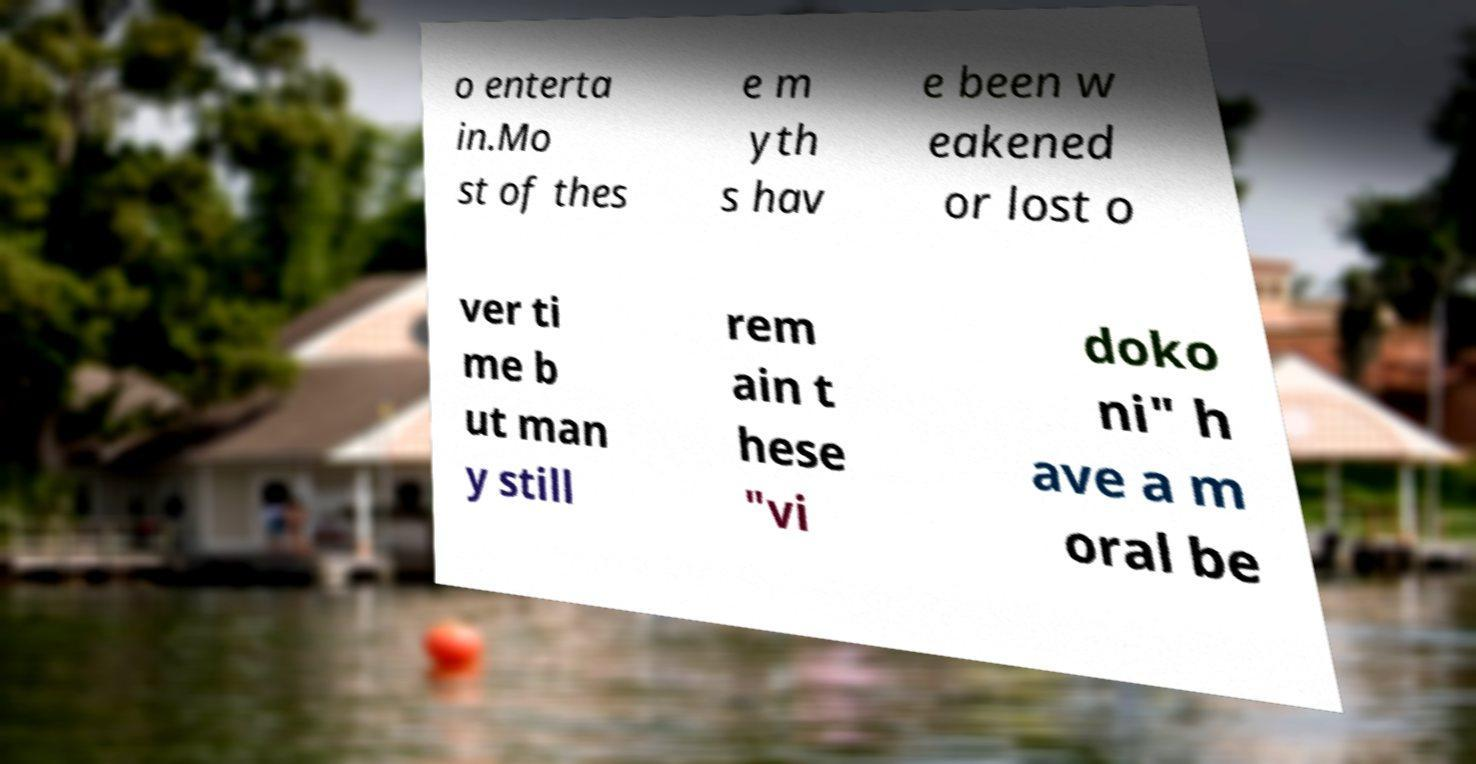I need the written content from this picture converted into text. Can you do that? o enterta in.Mo st of thes e m yth s hav e been w eakened or lost o ver ti me b ut man y still rem ain t hese "vi doko ni" h ave a m oral be 